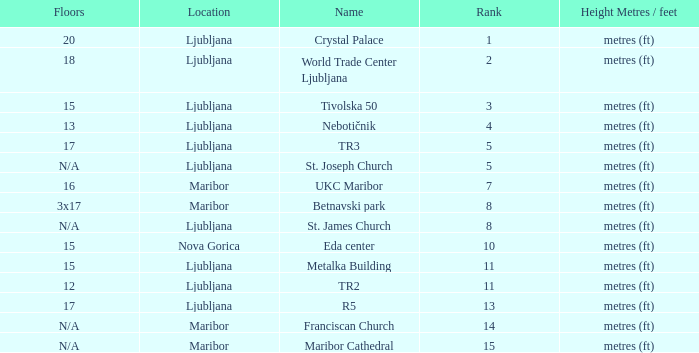Which Rank is the lowest one that has a Name of maribor cathedral? 15.0. 